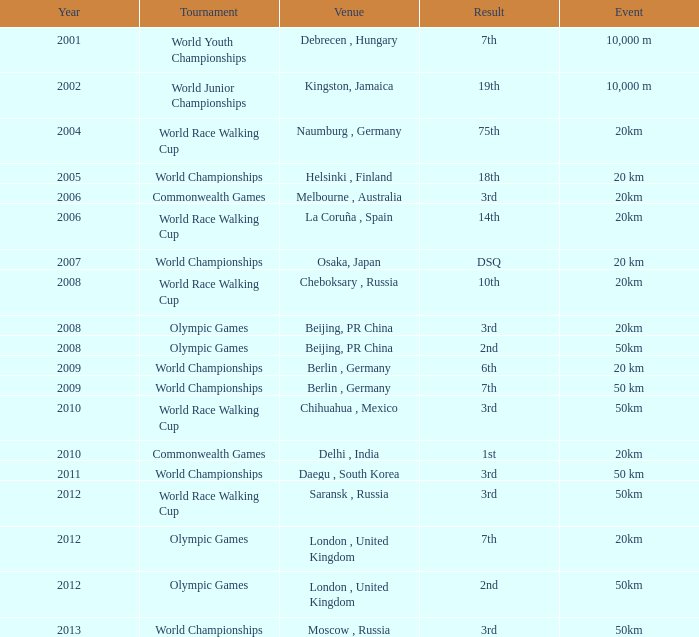What is earliest year that had a 50km event with a 2nd place result played in London, United Kingdom? 2012.0. 